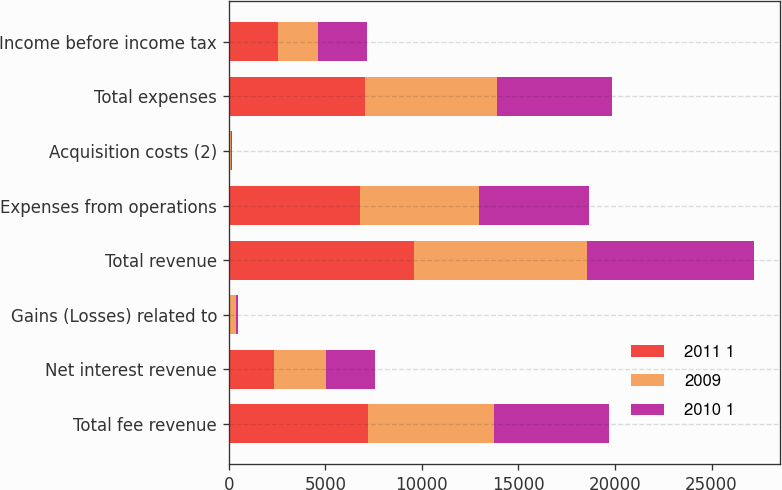<chart> <loc_0><loc_0><loc_500><loc_500><stacked_bar_chart><ecel><fcel>Total fee revenue<fcel>Net interest revenue<fcel>Gains (Losses) related to<fcel>Total revenue<fcel>Expenses from operations<fcel>Acquisition costs (2)<fcel>Total expenses<fcel>Income before income tax<nl><fcel>2011 1<fcel>7194<fcel>2333<fcel>67<fcel>9594<fcel>6789<fcel>16<fcel>7058<fcel>2536<nl><fcel>2009<fcel>6540<fcel>2699<fcel>286<fcel>8953<fcel>6176<fcel>96<fcel>6842<fcel>2086<nl><fcel>2010 1<fcel>5935<fcel>2564<fcel>141<fcel>8640<fcel>5667<fcel>49<fcel>5966<fcel>2525<nl></chart> 